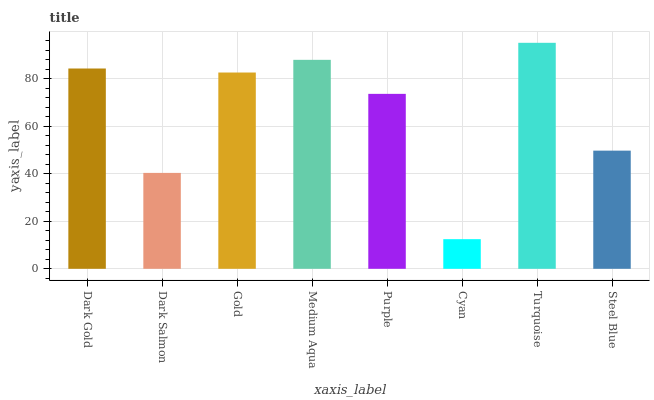Is Dark Salmon the minimum?
Answer yes or no. No. Is Dark Salmon the maximum?
Answer yes or no. No. Is Dark Gold greater than Dark Salmon?
Answer yes or no. Yes. Is Dark Salmon less than Dark Gold?
Answer yes or no. Yes. Is Dark Salmon greater than Dark Gold?
Answer yes or no. No. Is Dark Gold less than Dark Salmon?
Answer yes or no. No. Is Gold the high median?
Answer yes or no. Yes. Is Purple the low median?
Answer yes or no. Yes. Is Medium Aqua the high median?
Answer yes or no. No. Is Medium Aqua the low median?
Answer yes or no. No. 